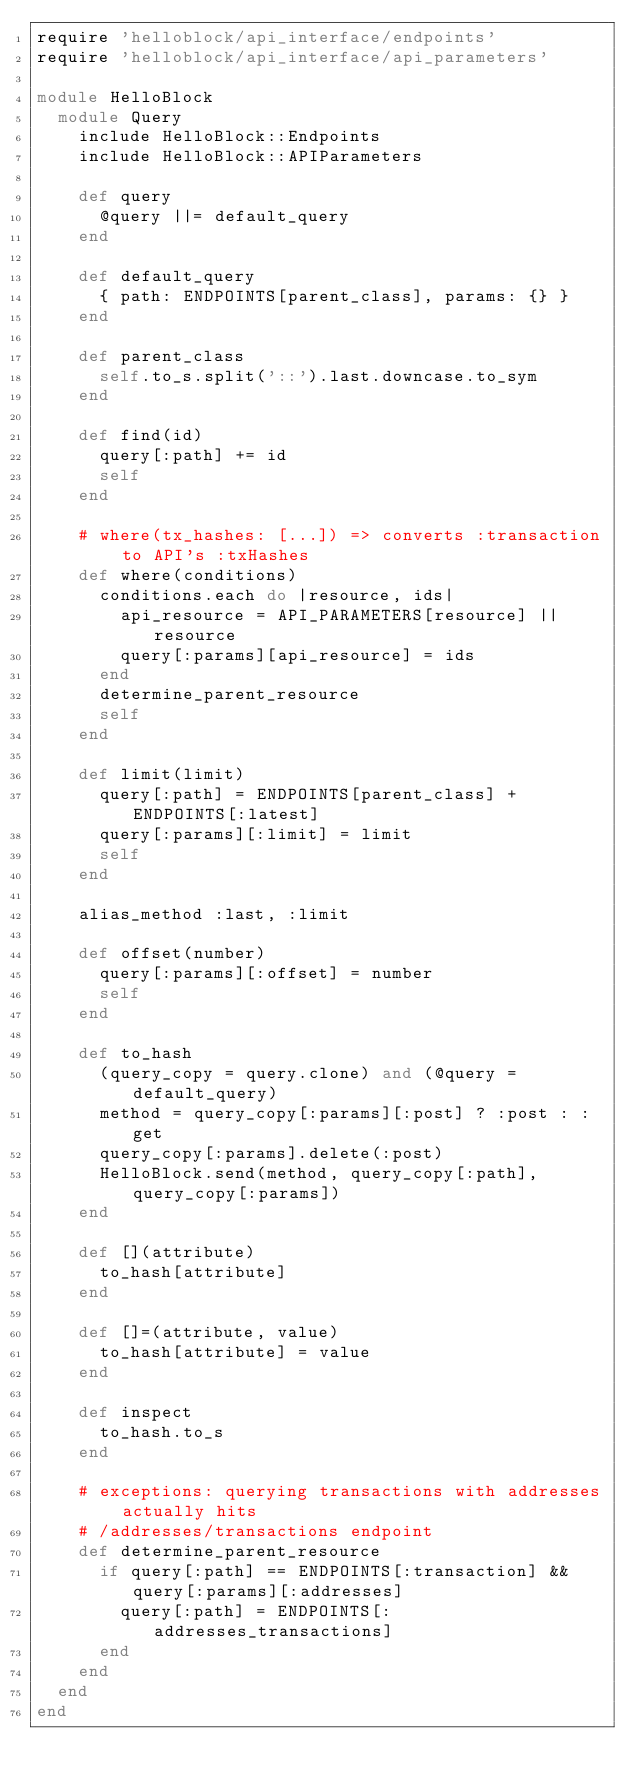Convert code to text. <code><loc_0><loc_0><loc_500><loc_500><_Ruby_>require 'helloblock/api_interface/endpoints'
require 'helloblock/api_interface/api_parameters'

module HelloBlock
  module Query
    include HelloBlock::Endpoints
    include HelloBlock::APIParameters

    def query
      @query ||= default_query
    end

    def default_query
      { path: ENDPOINTS[parent_class], params: {} }
    end

    def parent_class
      self.to_s.split('::').last.downcase.to_sym
    end

    def find(id)
      query[:path] += id
      self
    end

    # where(tx_hashes: [...]) => converts :transaction to API's :txHashes
    def where(conditions)
      conditions.each do |resource, ids|
        api_resource = API_PARAMETERS[resource] || resource
        query[:params][api_resource] = ids
      end
      determine_parent_resource
      self
    end

    def limit(limit)
      query[:path] = ENDPOINTS[parent_class] + ENDPOINTS[:latest]
      query[:params][:limit] = limit
      self
    end

    alias_method :last, :limit

    def offset(number)
      query[:params][:offset] = number
      self
    end

    def to_hash
      (query_copy = query.clone) and (@query = default_query)
      method = query_copy[:params][:post] ? :post : :get
      query_copy[:params].delete(:post)
      HelloBlock.send(method, query_copy[:path], query_copy[:params])
    end

    def [](attribute)
      to_hash[attribute]
    end

    def []=(attribute, value)
      to_hash[attribute] = value
    end

    def inspect
      to_hash.to_s
    end

    # exceptions: querying transactions with addresses actually hits
    # /addresses/transactions endpoint
    def determine_parent_resource
      if query[:path] == ENDPOINTS[:transaction] && query[:params][:addresses]
        query[:path] = ENDPOINTS[:addresses_transactions]
      end
    end
  end
end
</code> 